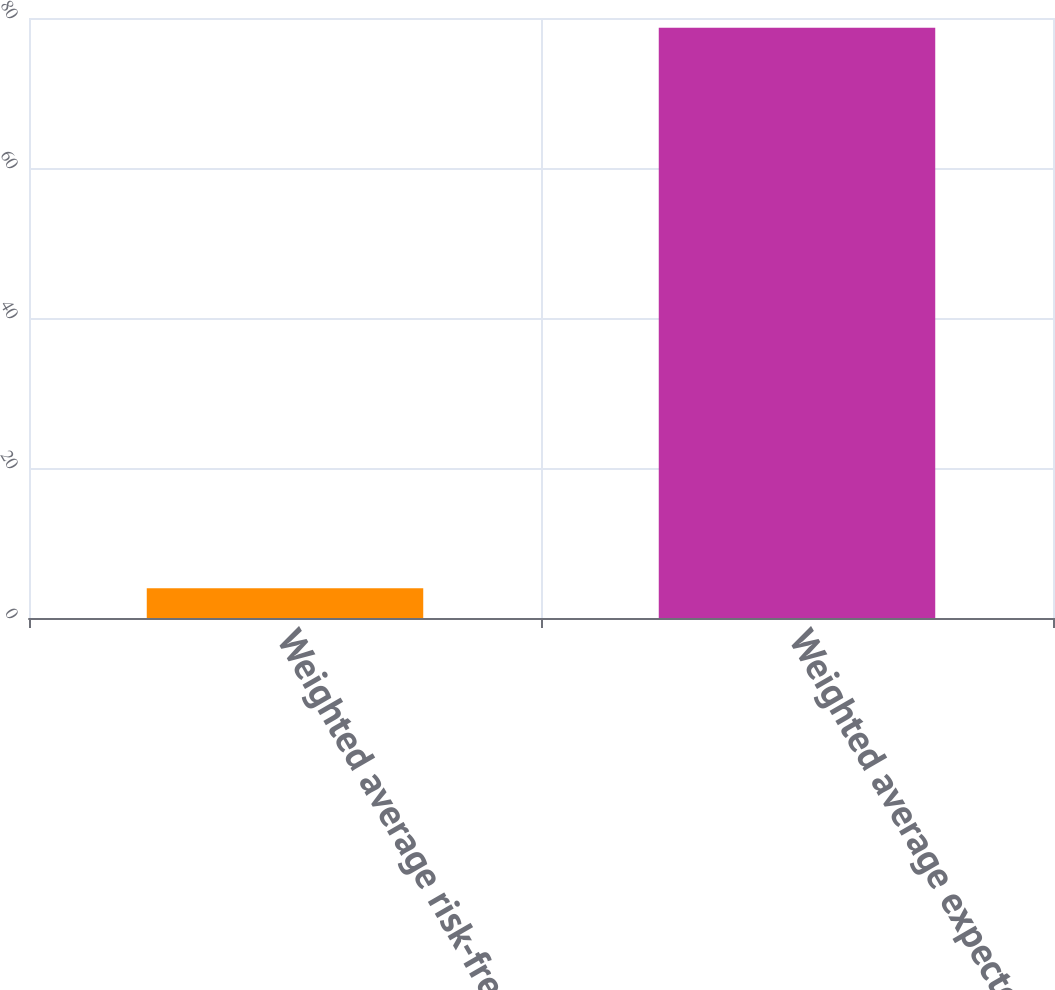Convert chart. <chart><loc_0><loc_0><loc_500><loc_500><bar_chart><fcel>Weighted average risk-free<fcel>Weighted average expected<nl><fcel>3.98<fcel>78.7<nl></chart> 